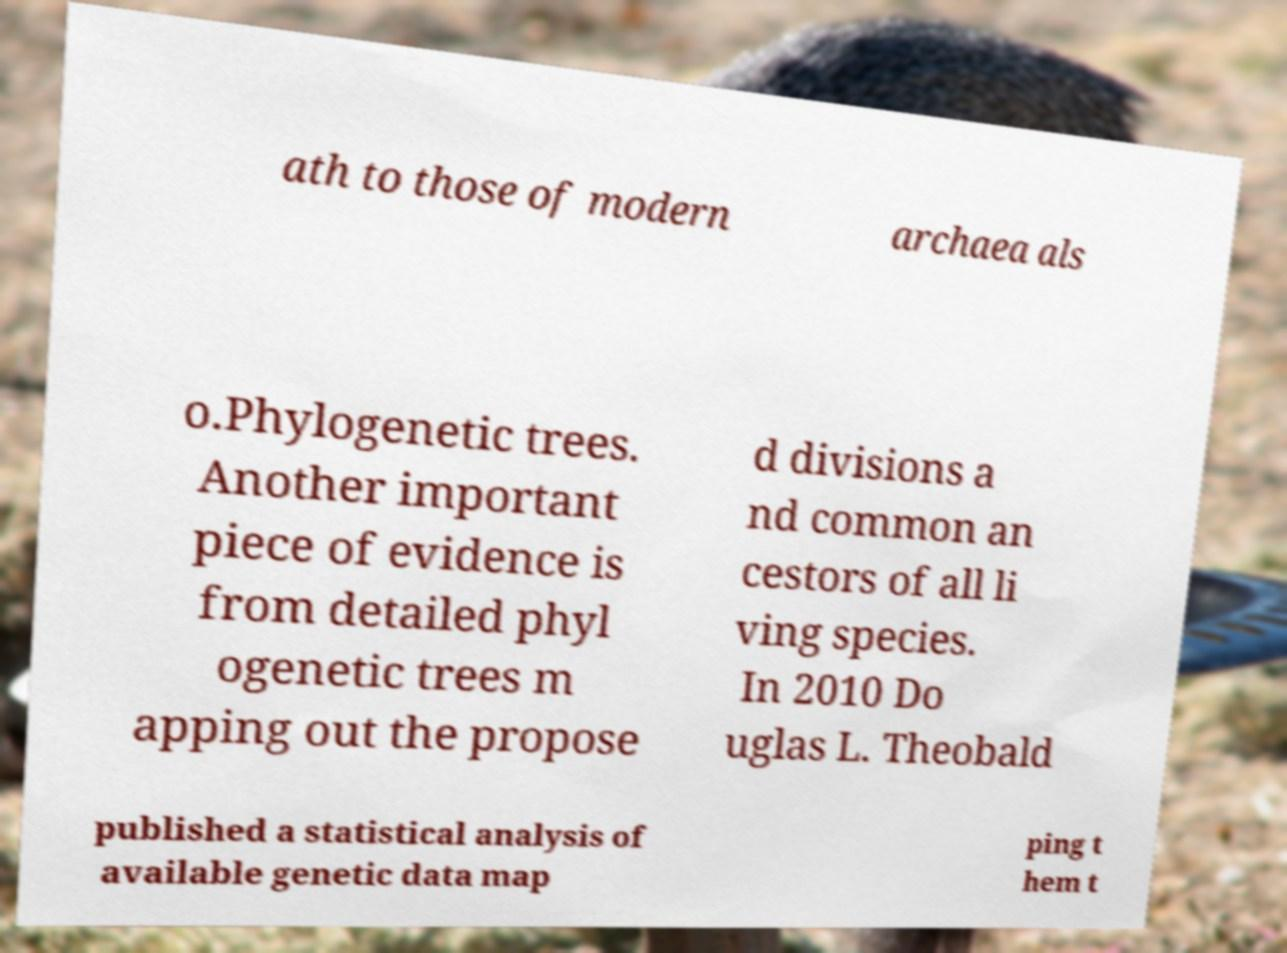There's text embedded in this image that I need extracted. Can you transcribe it verbatim? ath to those of modern archaea als o.Phylogenetic trees. Another important piece of evidence is from detailed phyl ogenetic trees m apping out the propose d divisions a nd common an cestors of all li ving species. In 2010 Do uglas L. Theobald published a statistical analysis of available genetic data map ping t hem t 